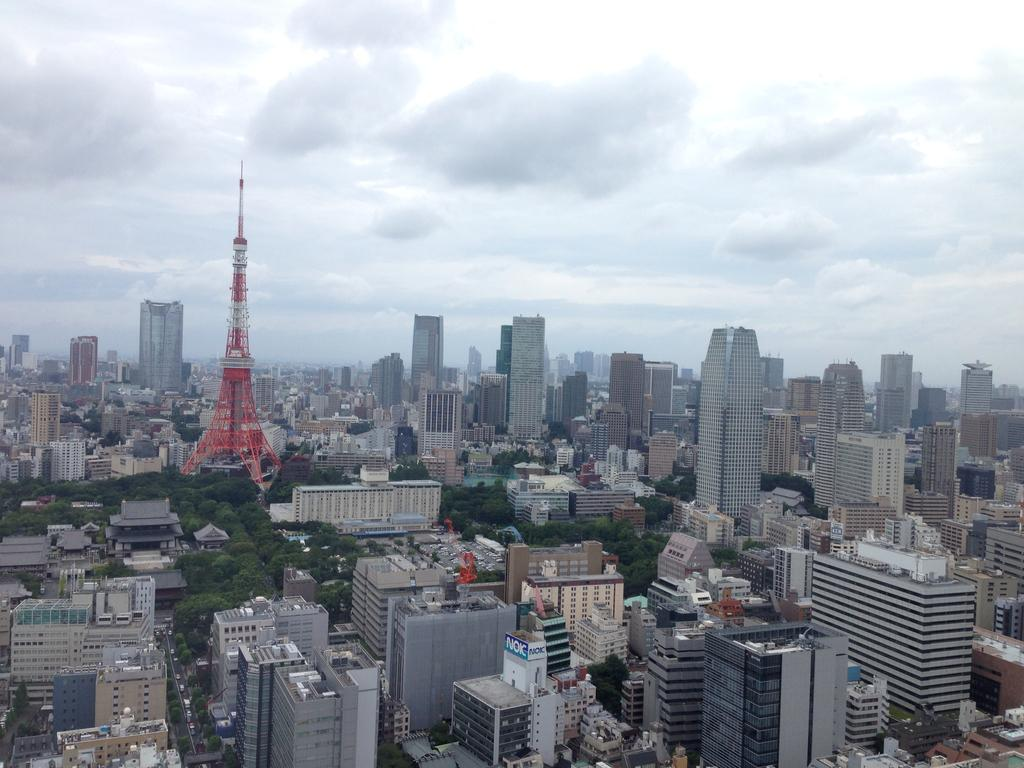What type of structures can be seen in the image? There are buildings in the image. What other natural elements are present in the image? There are trees in the image. What is the main feature located in the middle of the image? There is a tower in the middle of the image. What is visible in the background of the image? The sky is visible in the image. Can you hear the song being sung by the cobweb in the image? There is no song or cobweb present in the image. What type of death is depicted in the image? There is no death or any indication of death in the image. 